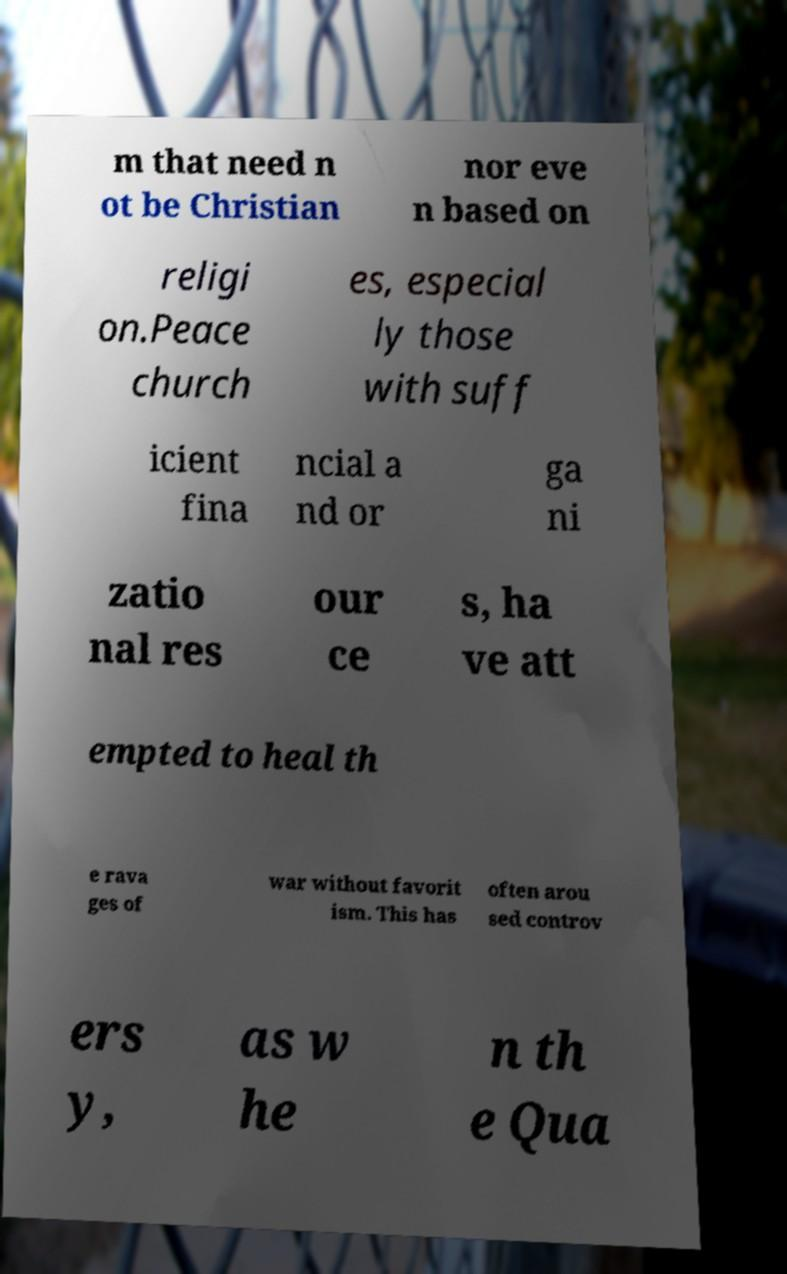What messages or text are displayed in this image? I need them in a readable, typed format. m that need n ot be Christian nor eve n based on religi on.Peace church es, especial ly those with suff icient fina ncial a nd or ga ni zatio nal res our ce s, ha ve att empted to heal th e rava ges of war without favorit ism. This has often arou sed controv ers y, as w he n th e Qua 